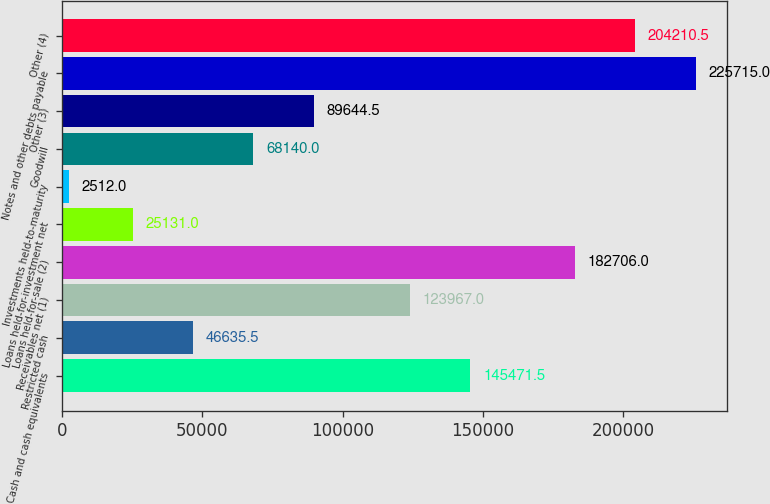<chart> <loc_0><loc_0><loc_500><loc_500><bar_chart><fcel>Cash and cash equivalents<fcel>Restricted cash<fcel>Receivables net (1)<fcel>Loans held-for-sale (2)<fcel>Loans held-for-investment net<fcel>Investments held-to-maturity<fcel>Goodwill<fcel>Other (3)<fcel>Notes and other debts payable<fcel>Other (4)<nl><fcel>145472<fcel>46635.5<fcel>123967<fcel>182706<fcel>25131<fcel>2512<fcel>68140<fcel>89644.5<fcel>225715<fcel>204210<nl></chart> 